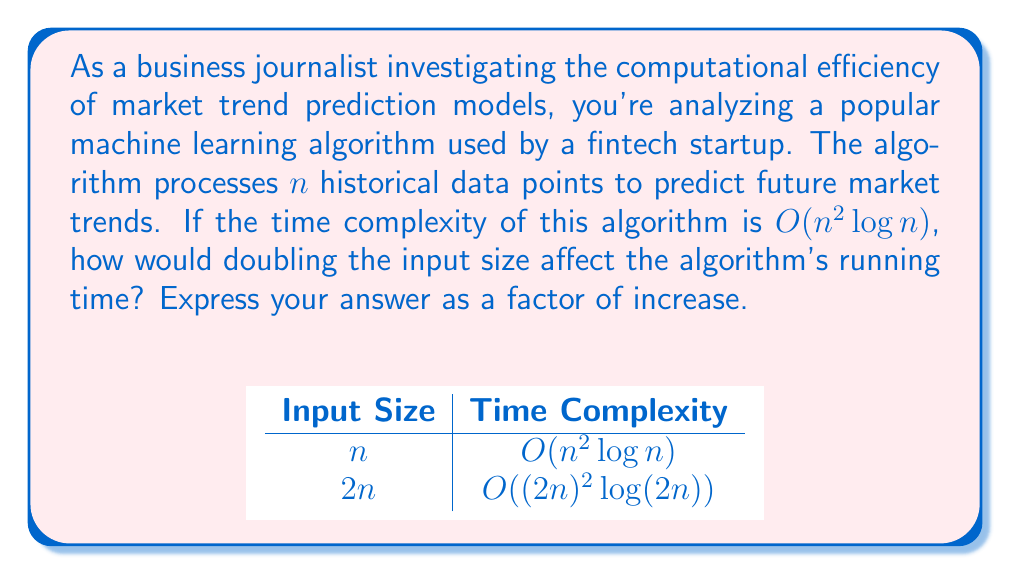Show me your answer to this math problem. Let's approach this step-by-step:

1) The given time complexity is $O(n^2 \log n)$.

2) We need to compare the running time for input size $n$ and $2n$.

3) For input size $n$:
   Time $\propto n^2 \log n$

4) For input size $2n$:
   Time $\propto (2n)^2 \log (2n)$

5) Let's expand this:
   $(2n)^2 \log (2n) = 4n^2 (\log 2 + \log n)$

6) Simplify:
   $4n^2 \log 2 + 4n^2 \log n$

7) Compare with original:
   $\frac{4n^2 \log 2 + 4n^2 \log n}{n^2 \log n}$

8) Simplify:
   $4 \frac{\log 2}{\log n} + 4$

9) As $n$ grows large, $\frac{\log 2}{\log n}$ approaches 0.

10) Therefore, for large $n$, the ratio approaches 4.

This means that doubling the input size will increase the running time by a factor of approximately 4 for large input sizes.
Answer: 4 